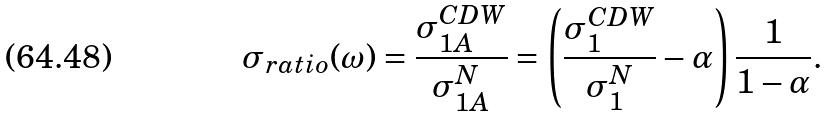<formula> <loc_0><loc_0><loc_500><loc_500>\sigma _ { r a t i o } ( \omega ) = \frac { \sigma _ { 1 A } ^ { C D W } } { \sigma _ { 1 A } ^ { N } } = \left ( \frac { \sigma _ { 1 } ^ { C D W } } { \sigma _ { 1 } ^ { N } } - \alpha \right ) \frac { 1 } { 1 - \alpha } .</formula> 